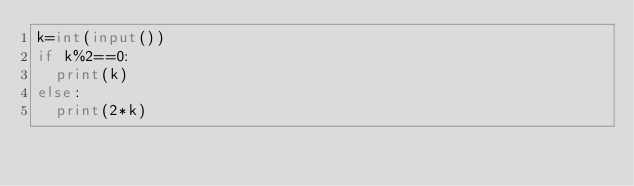Convert code to text. <code><loc_0><loc_0><loc_500><loc_500><_Python_>k=int(input())
if k%2==0:
  print(k)
else:
  print(2*k)</code> 